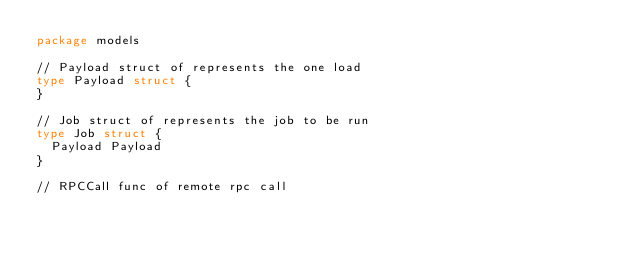Convert code to text. <code><loc_0><loc_0><loc_500><loc_500><_Go_>package models

// Payload struct of represents the one load
type Payload struct {
}

// Job struct of represents the job to be run
type Job struct {
	Payload Payload
}

// RPCCall func of remote rpc call</code> 